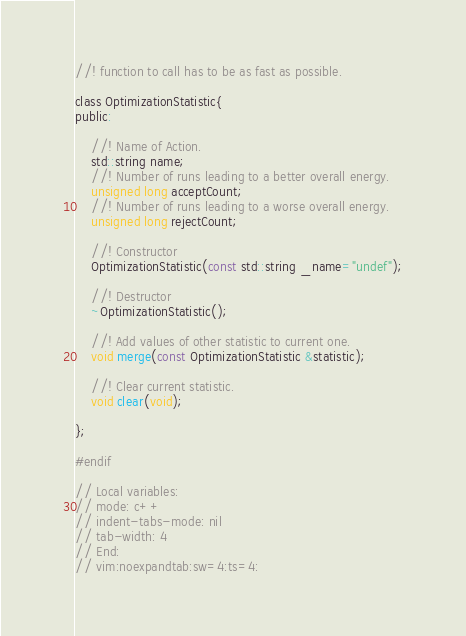<code> <loc_0><loc_0><loc_500><loc_500><_C_>//! function to call has to be as fast as possible.

class OptimizationStatistic{
public:

    //! Name of Action.
    std::string name;
    //! Number of runs leading to a better overall energy.
    unsigned long acceptCount;
    //! Number of runs leading to a worse overall energy.
    unsigned long rejectCount;
   
    //! Constructor
    OptimizationStatistic(const std::string _name="undef");

    //! Destructor
    ~OptimizationStatistic();

    //! Add values of other statistic to current one.
    void merge(const OptimizationStatistic &statistic);

    //! Clear current statistic.
    void clear(void);
    
};

#endif

// Local variables:
// mode: c++
// indent-tabs-mode: nil
// tab-width: 4
// End:
// vim:noexpandtab:sw=4:ts=4:
</code> 